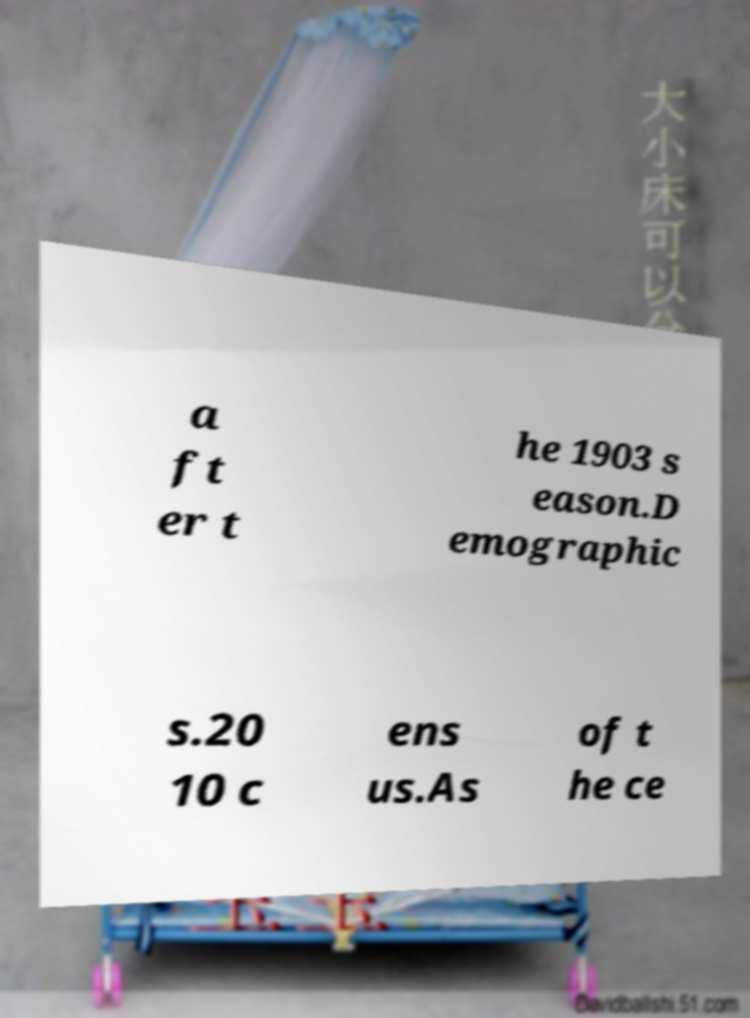Could you assist in decoding the text presented in this image and type it out clearly? a ft er t he 1903 s eason.D emographic s.20 10 c ens us.As of t he ce 